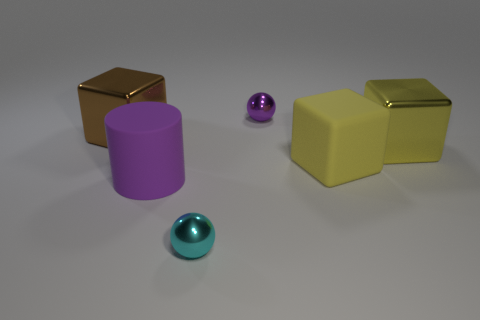Add 2 matte cylinders. How many objects exist? 8 Subtract all balls. How many objects are left? 4 Add 5 matte objects. How many matte objects exist? 7 Subtract 0 brown cylinders. How many objects are left? 6 Subtract all purple objects. Subtract all large brown metal things. How many objects are left? 3 Add 4 yellow metal objects. How many yellow metal objects are left? 5 